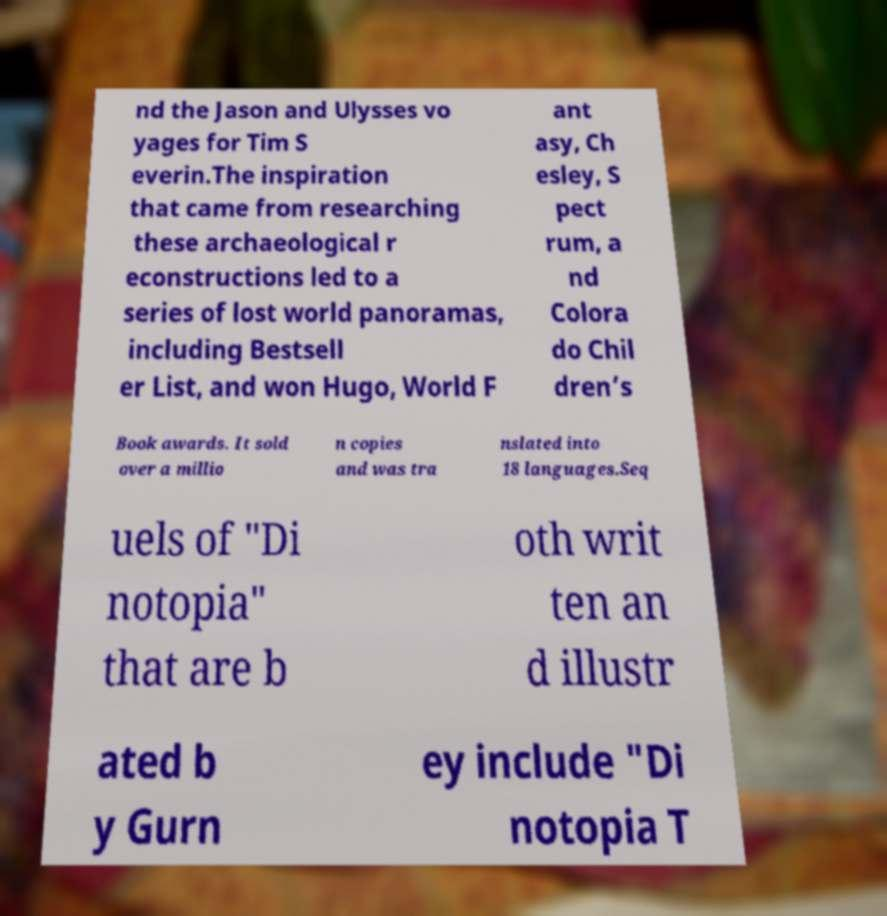Please read and relay the text visible in this image. What does it say? nd the Jason and Ulysses vo yages for Tim S everin.The inspiration that came from researching these archaeological r econstructions led to a series of lost world panoramas, including Bestsell er List, and won Hugo, World F ant asy, Ch esley, S pect rum, a nd Colora do Chil dren’s Book awards. It sold over a millio n copies and was tra nslated into 18 languages.Seq uels of "Di notopia" that are b oth writ ten an d illustr ated b y Gurn ey include "Di notopia T 